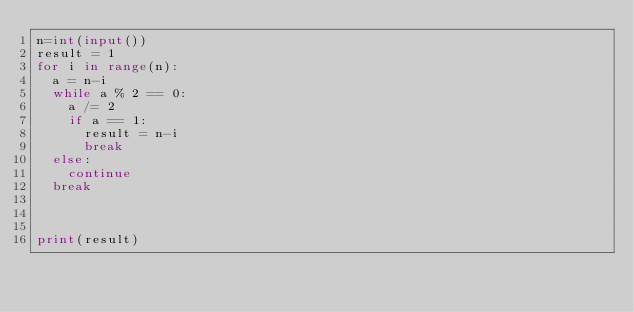Convert code to text. <code><loc_0><loc_0><loc_500><loc_500><_Python_>n=int(input())
result = 1
for i in range(n):
  a = n-i
  while a % 2 == 0:
    a /= 2
    if a == 1:
      result = n-i
      break
  else:
    continue
  break
  
  

print(result)</code> 